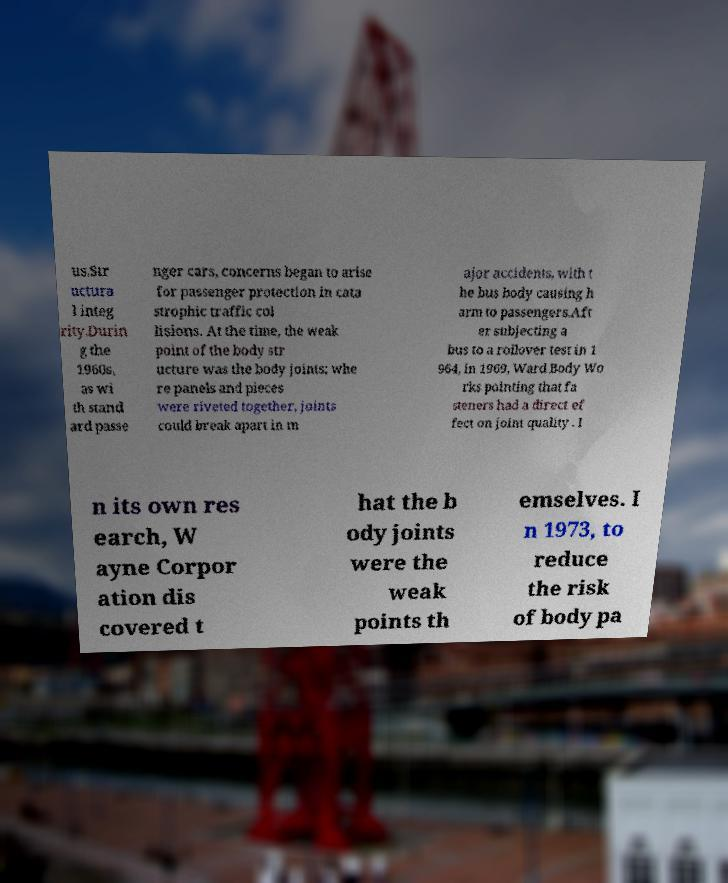Please identify and transcribe the text found in this image. us.Str uctura l integ rity.Durin g the 1960s, as wi th stand ard passe nger cars, concerns began to arise for passenger protection in cata strophic traffic col lisions. At the time, the weak point of the body str ucture was the body joints; whe re panels and pieces were riveted together, joints could break apart in m ajor accidents, with t he bus body causing h arm to passengers.Aft er subjecting a bus to a rollover test in 1 964, in 1969, Ward Body Wo rks pointing that fa steners had a direct ef fect on joint quality . I n its own res earch, W ayne Corpor ation dis covered t hat the b ody joints were the weak points th emselves. I n 1973, to reduce the risk of body pa 